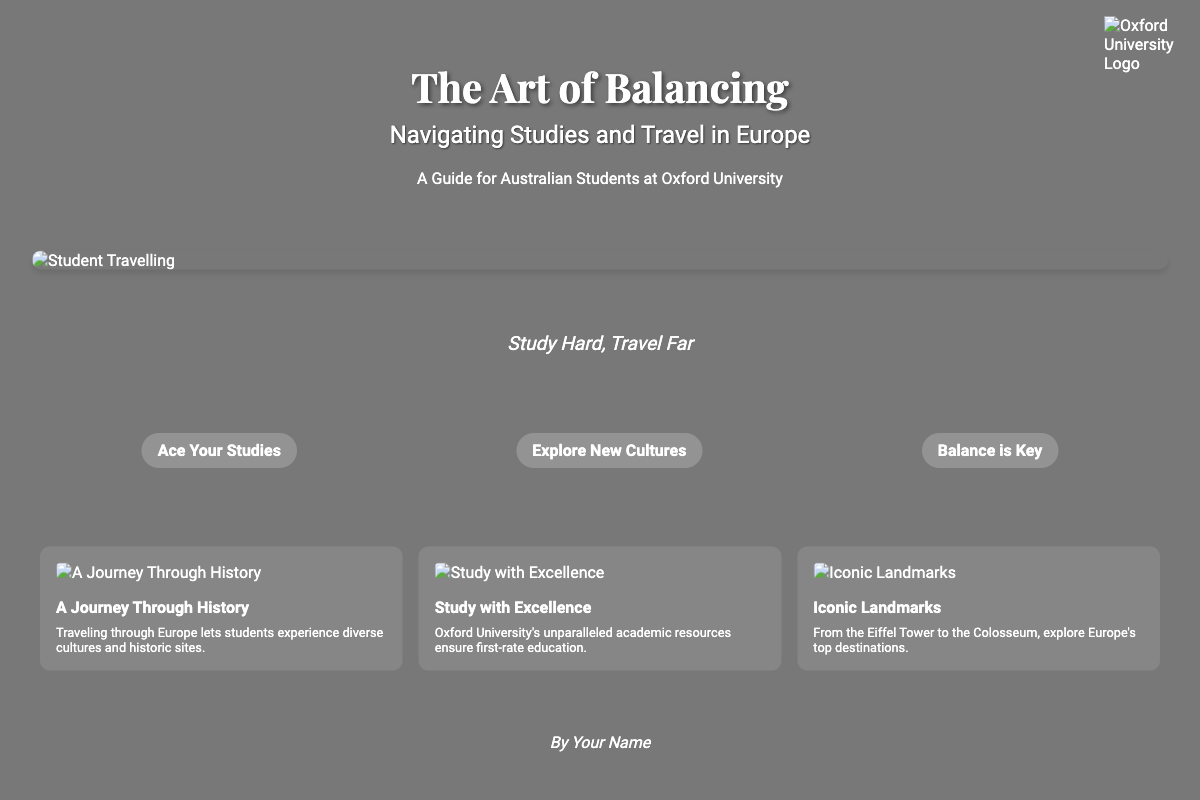what is the title of the book? The title is prominently displayed at the top of the cover in large font.
Answer: The Art of Balancing who is the book aimed at? The subtitle indicates that the book is designed specifically for a certain group.
Answer: Australian Students at Oxford University what is the tagline of the book? The tagline is presented centrally after the main title, providing a succinct message.
Answer: Study Hard, Travel Far how many catchphrases are listed? The cover features a specific number of catchphrases to encapsulate themes of the book.
Answer: Three what type of image is used as the main image? The document describes the content of the main image, giving insight into its thematic relevance.
Answer: Student Travelling what is depicted in the second cover element? The second element details the value of the studying experience related to the university.
Answer: Study with Excellence which iconic landmarks are mentioned? The document lists notable attractions as part of the book’s travel guidance.
Answer: Eiffel Tower, Colosseum who is the author listed on the cover? The author’s name is mentioned at the bottom of the cover, contributing to the book's credibility.
Answer: Your Name what is the background image of the cover? The cover features a specific visual that sets the tone for the book and is related to the context.
Answer: Europe map background 